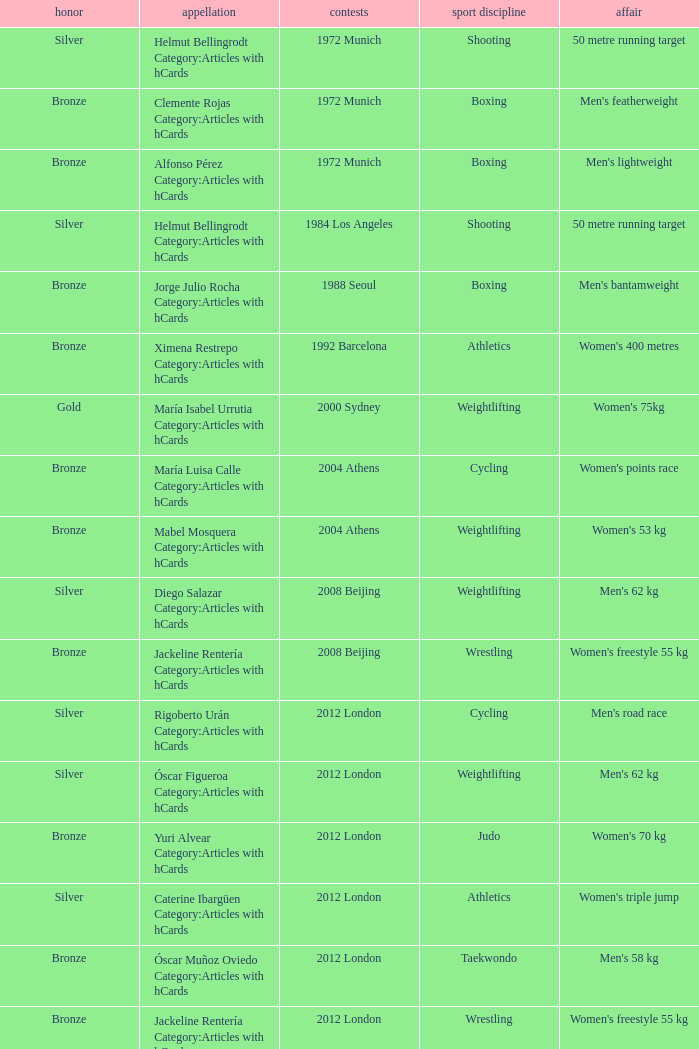What wrestling event was participated in during the 2008 Beijing games? Women's freestyle 55 kg. 